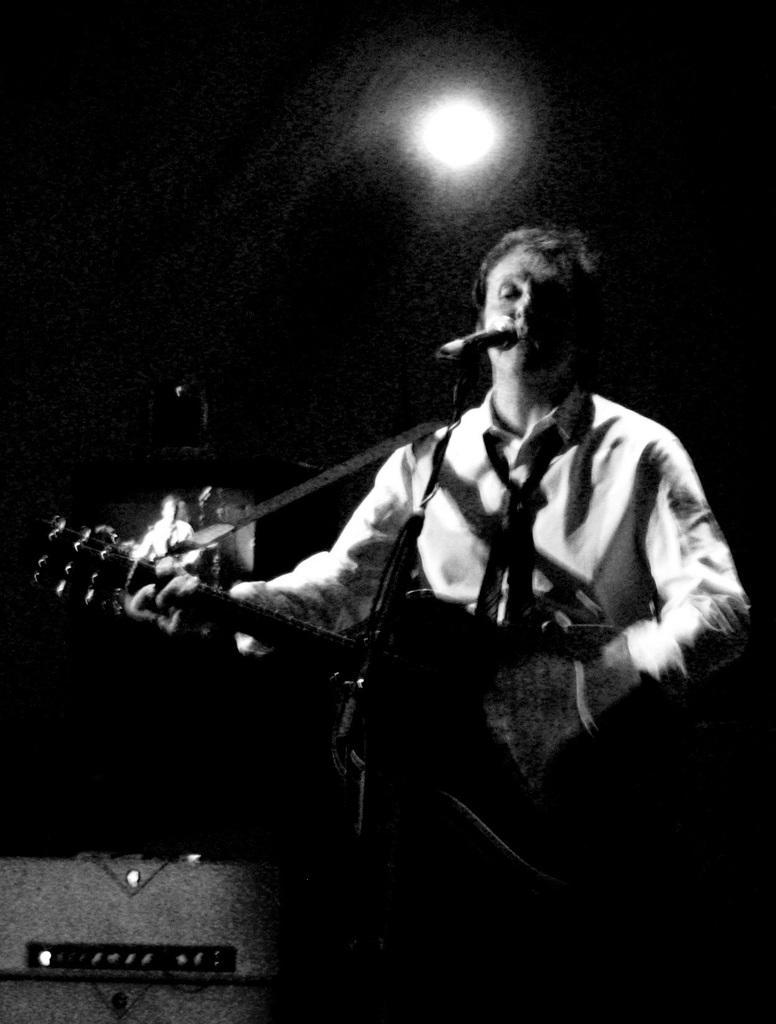How would you summarize this image in a sentence or two? There is a person playing a guitar in front of a microphone. He is singing. Behind him there is a light. 